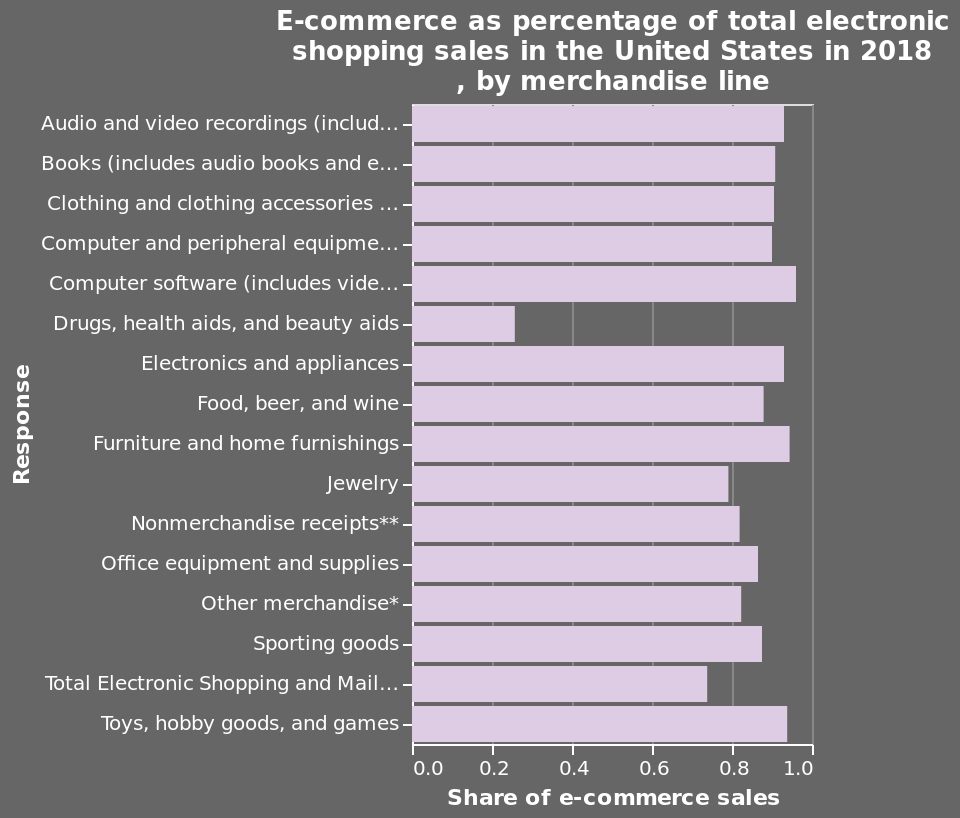<image>
What does the y-axis represent in the given bar graph?  The y-axis in the bar graph represents the variable "Response". What does the bar graph represent?  The bar graph represents the percentage of total electronic shopping sales in the United States in 2018, categorized by different merchandise lines. 